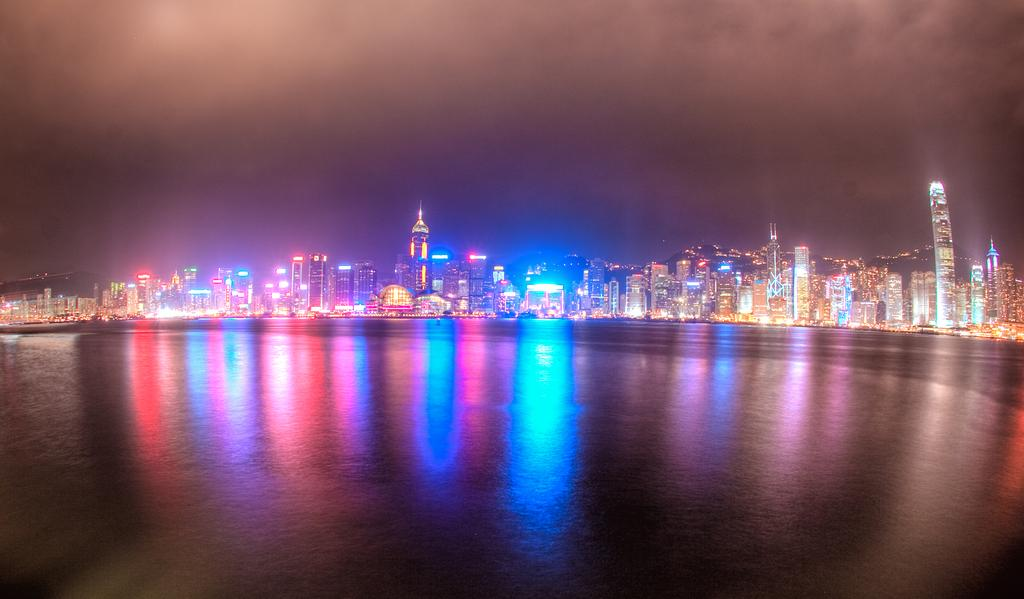What type of structures can be seen in the image? There are many buildings and skyscrapers in the image. Can you describe the natural element present in the image? There is a reflection of light on the sea water in the image. What type of authority figure can be seen in the image? There is no authority figure present in the image. What type of pleasure activity is taking place in the image? There is no pleasure activity depicted in the image. 